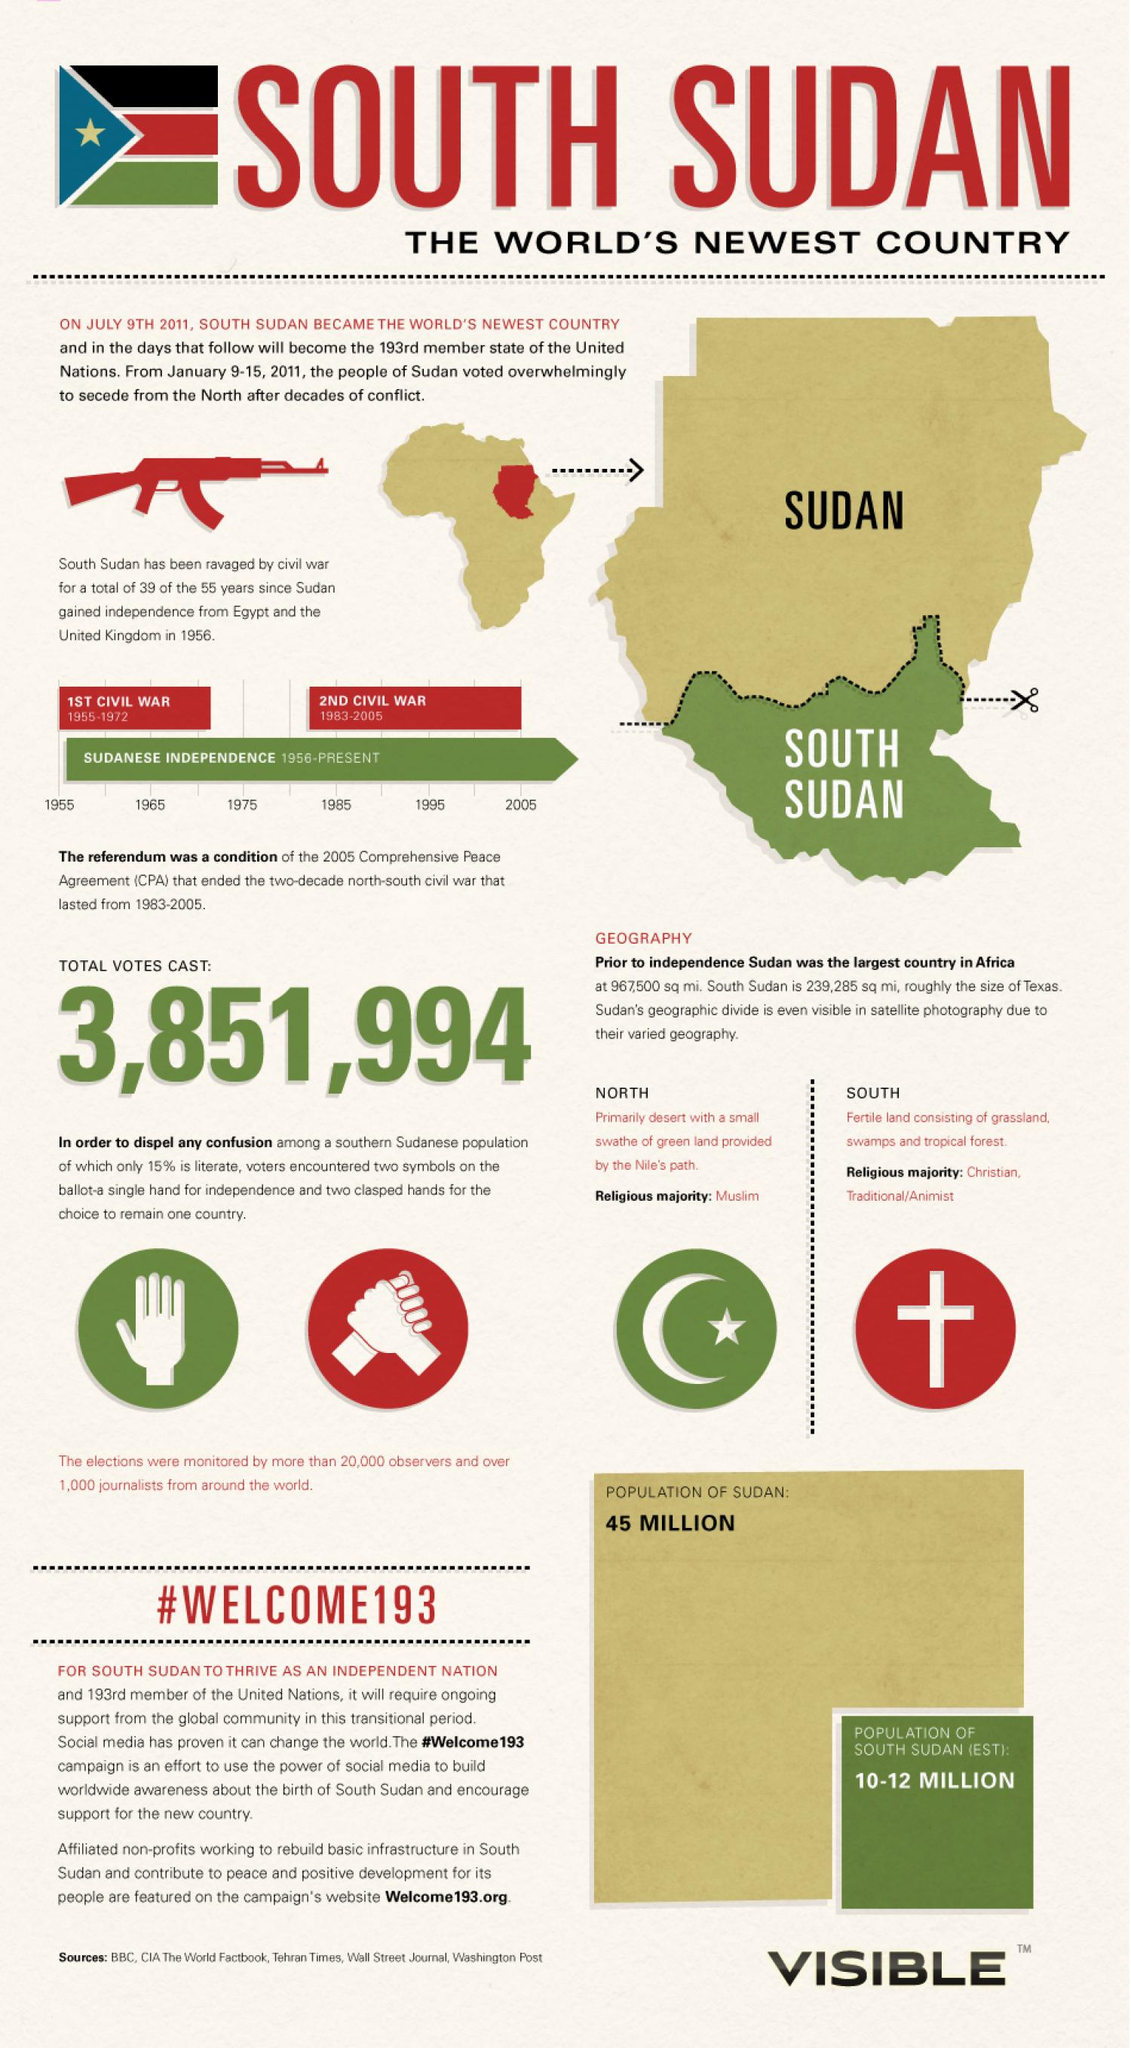List a handful of essential elements in this visual. Sudan gained its independence from Britain in 1956. The Second Sudanese Civil War began in 1983. The religious majority in North Sudan is Muslim. There have been two civil wars in Sudan, according to historical records. 